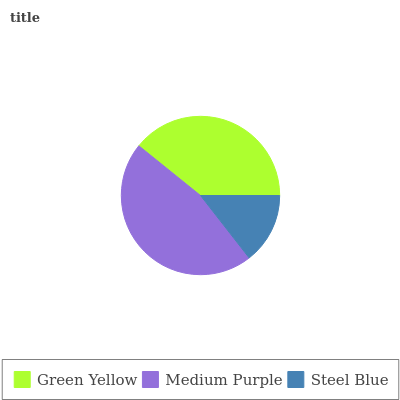Is Steel Blue the minimum?
Answer yes or no. Yes. Is Medium Purple the maximum?
Answer yes or no. Yes. Is Medium Purple the minimum?
Answer yes or no. No. Is Steel Blue the maximum?
Answer yes or no. No. Is Medium Purple greater than Steel Blue?
Answer yes or no. Yes. Is Steel Blue less than Medium Purple?
Answer yes or no. Yes. Is Steel Blue greater than Medium Purple?
Answer yes or no. No. Is Medium Purple less than Steel Blue?
Answer yes or no. No. Is Green Yellow the high median?
Answer yes or no. Yes. Is Green Yellow the low median?
Answer yes or no. Yes. Is Medium Purple the high median?
Answer yes or no. No. Is Medium Purple the low median?
Answer yes or no. No. 